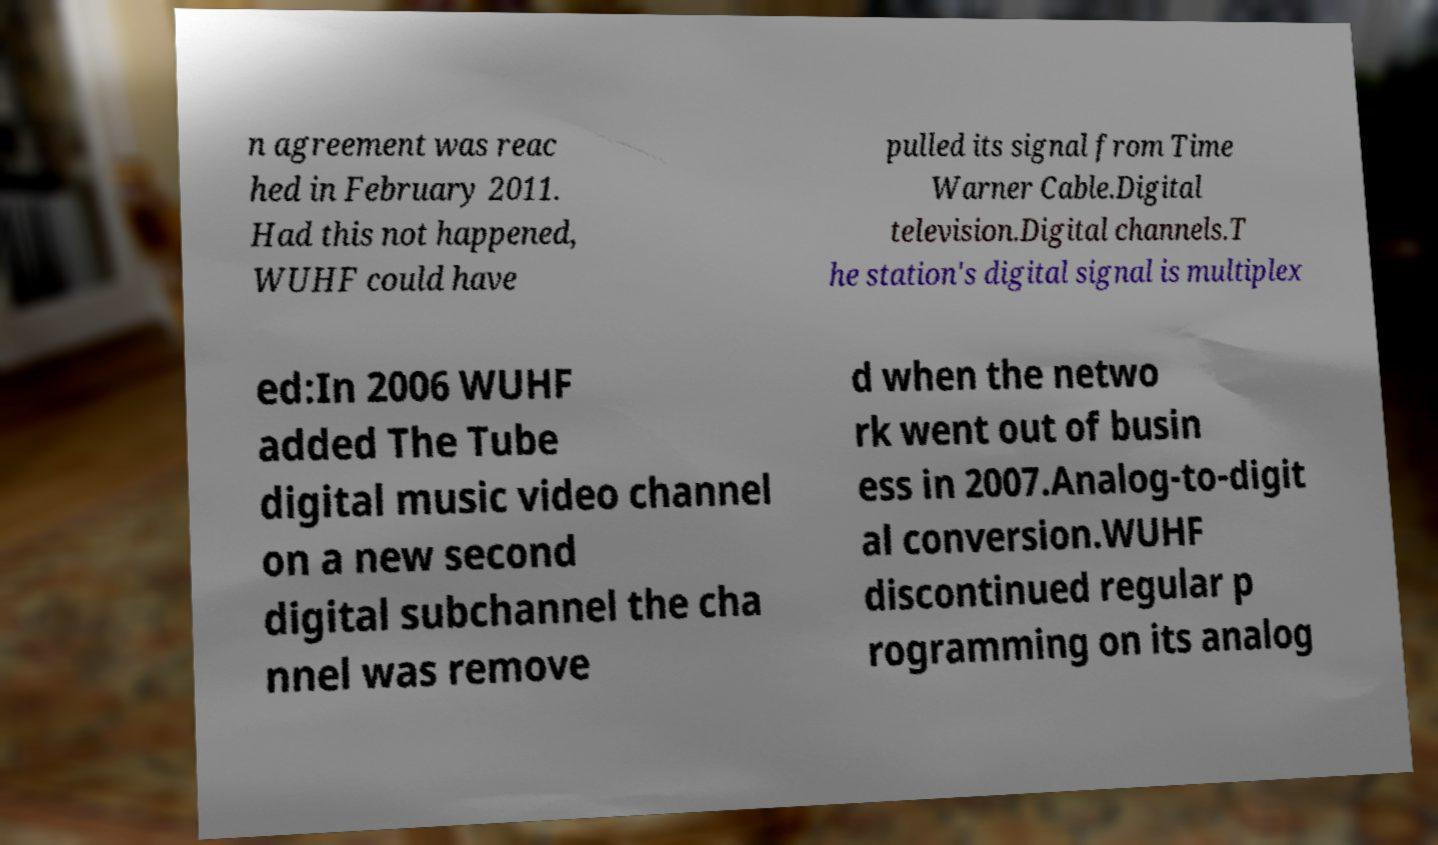Could you assist in decoding the text presented in this image and type it out clearly? n agreement was reac hed in February 2011. Had this not happened, WUHF could have pulled its signal from Time Warner Cable.Digital television.Digital channels.T he station's digital signal is multiplex ed:In 2006 WUHF added The Tube digital music video channel on a new second digital subchannel the cha nnel was remove d when the netwo rk went out of busin ess in 2007.Analog-to-digit al conversion.WUHF discontinued regular p rogramming on its analog 